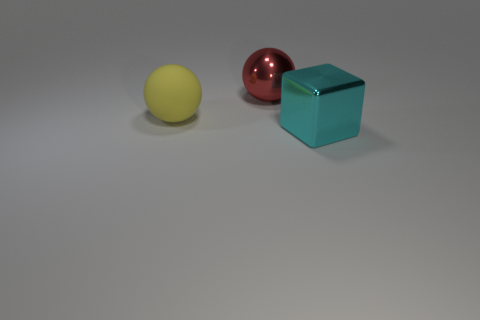Subtract all cubes. How many objects are left? 2 Subtract 1 blocks. How many blocks are left? 0 Add 1 yellow objects. How many objects exist? 4 Subtract 0 gray spheres. How many objects are left? 3 Subtract all purple spheres. Subtract all brown cylinders. How many spheres are left? 2 Subtract all blue cubes. How many green spheres are left? 0 Subtract all large shiny cylinders. Subtract all balls. How many objects are left? 1 Add 1 big balls. How many big balls are left? 3 Add 1 red balls. How many red balls exist? 2 Subtract all red balls. How many balls are left? 1 